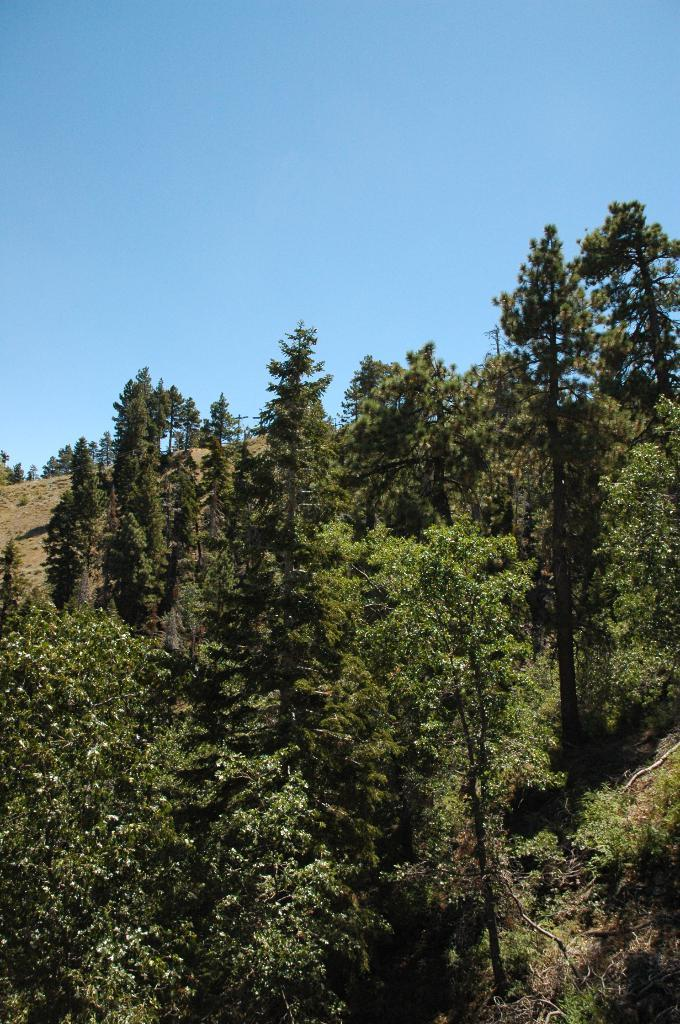What type of vegetation can be seen in the image? There are trees in the image. What color is the sky in the image? The sky is blue in the image. What is the name of the peace treaty signed under the tree in the image? There is no peace treaty or any indication of a treaty being signed in the image. 